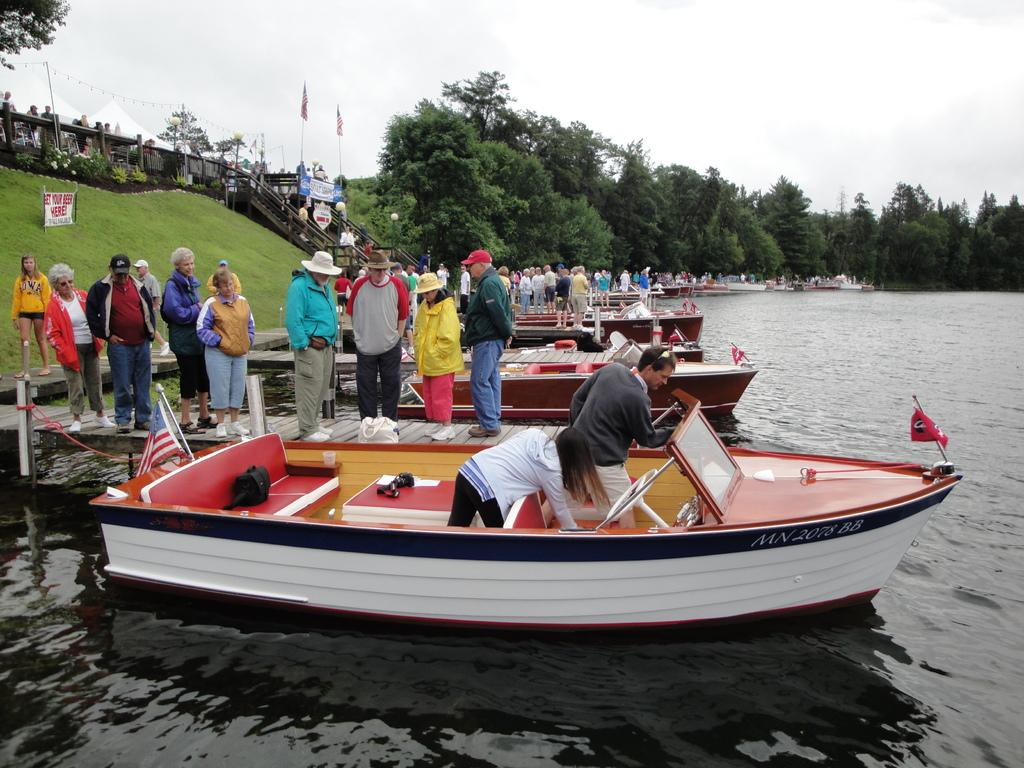<image>
Render a clear and concise summary of the photo. many boats are tied to the shore where they can buy beer 